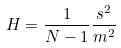Convert formula to latex. <formula><loc_0><loc_0><loc_500><loc_500>H = \frac { 1 } { N - 1 } \frac { s ^ { 2 } } { m ^ { 2 } }</formula> 